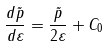Convert formula to latex. <formula><loc_0><loc_0><loc_500><loc_500>\frac { d \tilde { p } } { d \varepsilon } = \frac { \tilde { p } } { 2 \varepsilon } + C _ { 0 }</formula> 